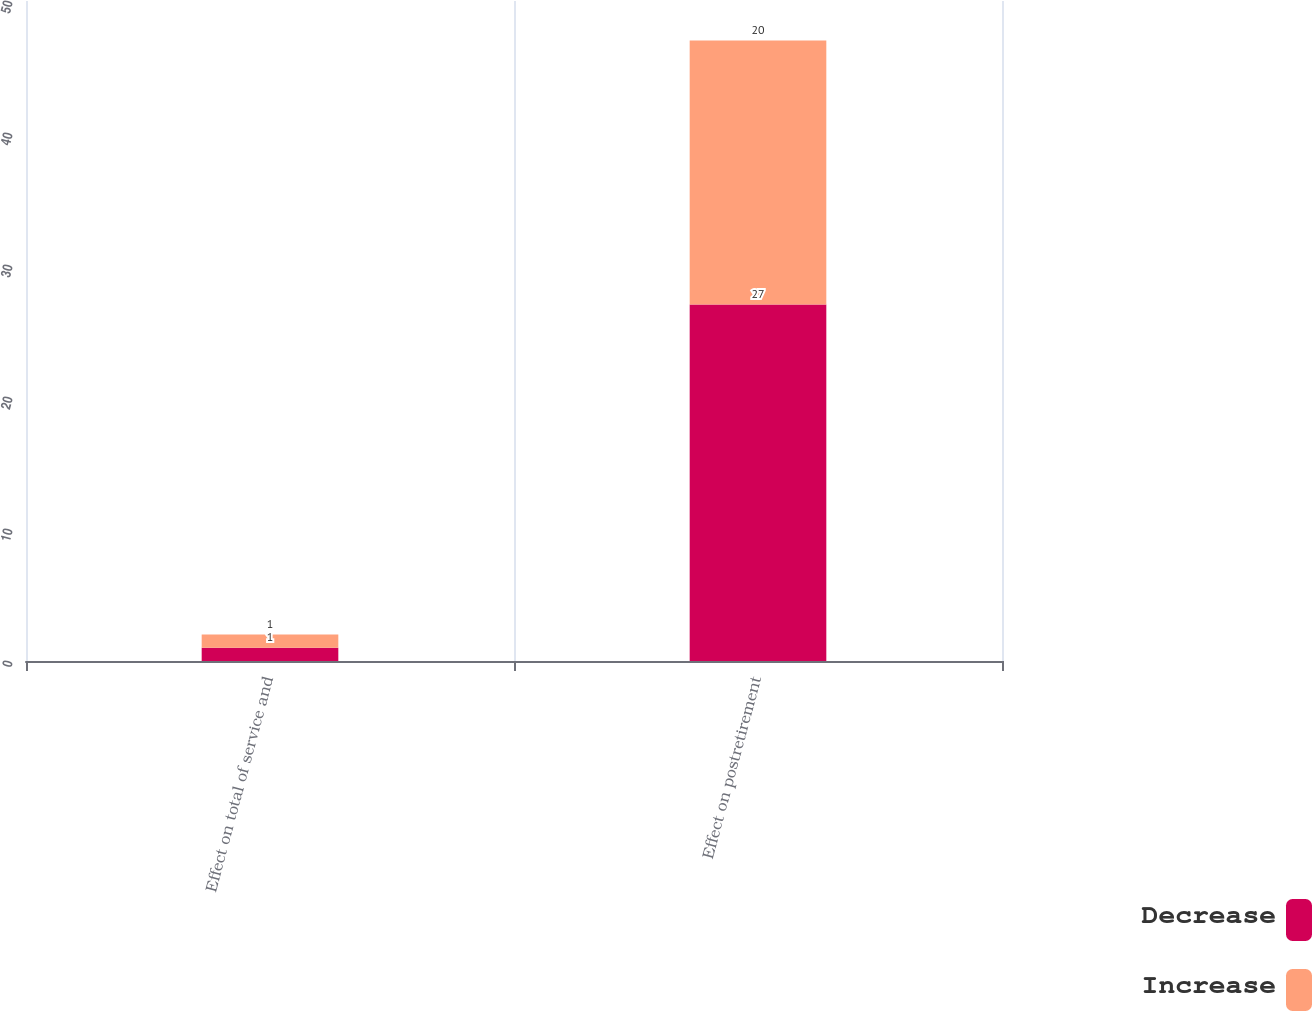Convert chart. <chart><loc_0><loc_0><loc_500><loc_500><stacked_bar_chart><ecel><fcel>Effect on total of service and<fcel>Effect on postretirement<nl><fcel>Decrease<fcel>1<fcel>27<nl><fcel>Increase<fcel>1<fcel>20<nl></chart> 